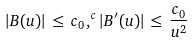Convert formula to latex. <formula><loc_0><loc_0><loc_500><loc_500>| B ( u ) | \, \leq \, c _ { 0 } \, , ^ { c } | B ^ { \prime } ( u ) | \, \leq \, \frac { c _ { 0 } } { u ^ { 2 } }</formula> 